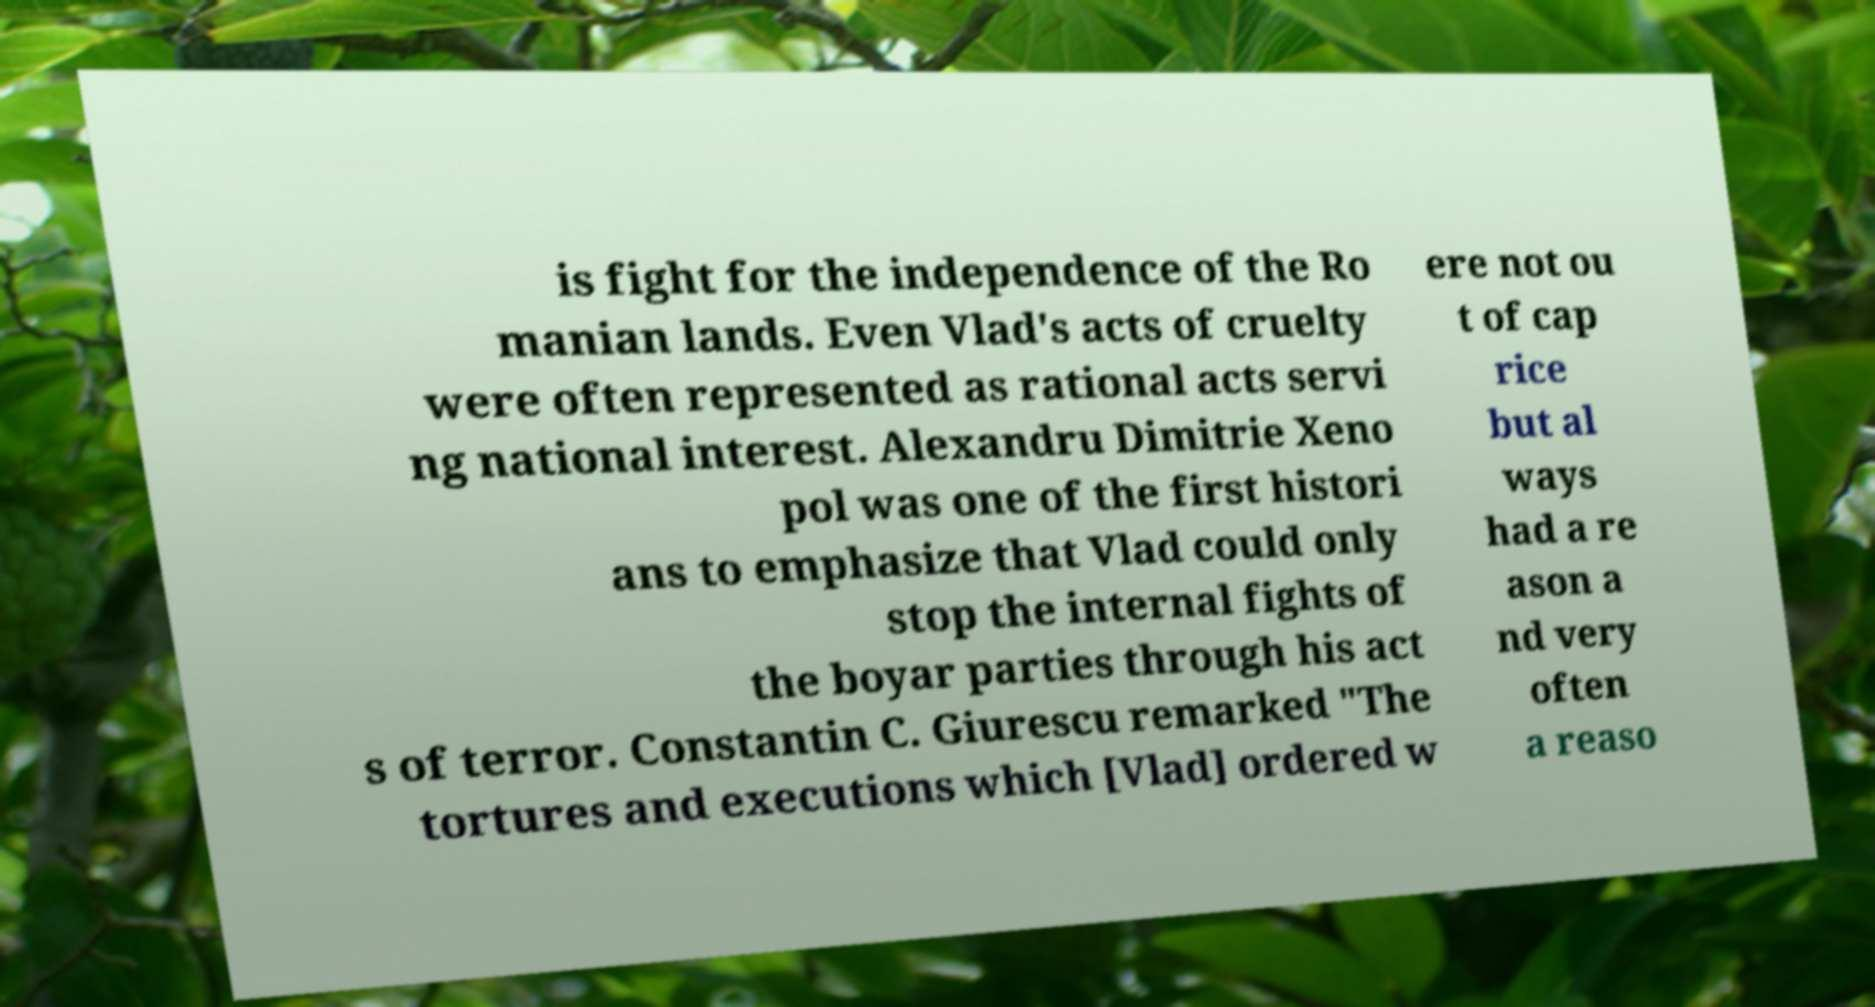There's text embedded in this image that I need extracted. Can you transcribe it verbatim? is fight for the independence of the Ro manian lands. Even Vlad's acts of cruelty were often represented as rational acts servi ng national interest. Alexandru Dimitrie Xeno pol was one of the first histori ans to emphasize that Vlad could only stop the internal fights of the boyar parties through his act s of terror. Constantin C. Giurescu remarked "The tortures and executions which [Vlad] ordered w ere not ou t of cap rice but al ways had a re ason a nd very often a reaso 